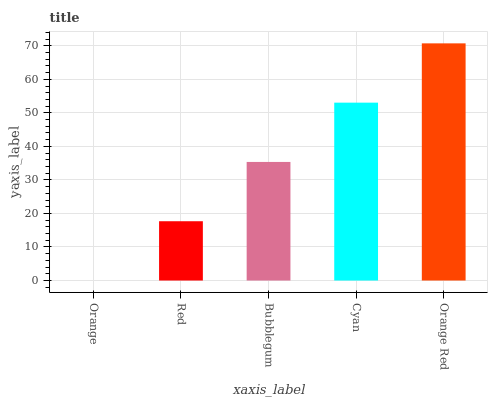Is Orange the minimum?
Answer yes or no. Yes. Is Orange Red the maximum?
Answer yes or no. Yes. Is Red the minimum?
Answer yes or no. No. Is Red the maximum?
Answer yes or no. No. Is Red greater than Orange?
Answer yes or no. Yes. Is Orange less than Red?
Answer yes or no. Yes. Is Orange greater than Red?
Answer yes or no. No. Is Red less than Orange?
Answer yes or no. No. Is Bubblegum the high median?
Answer yes or no. Yes. Is Bubblegum the low median?
Answer yes or no. Yes. Is Red the high median?
Answer yes or no. No. Is Orange the low median?
Answer yes or no. No. 